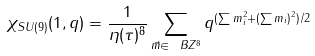Convert formula to latex. <formula><loc_0><loc_0><loc_500><loc_500>\chi _ { S U ( 9 ) } ( { 1 } , q ) = \frac { 1 } { \eta ( \tau ) ^ { 8 } } \sum _ { \vec { m } \in \ B Z ^ { 8 } } q ^ { ( \sum m _ { i } ^ { 2 } + ( \sum m _ { i } ) ^ { 2 } ) / 2 }</formula> 